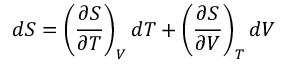Convert formula to latex. <formula><loc_0><loc_0><loc_500><loc_500>d S = \left ( { \frac { \partial S } { \partial T } } \right ) _ { V } d T + \left ( { \frac { \partial S } { \partial V } } \right ) _ { T } d V</formula> 